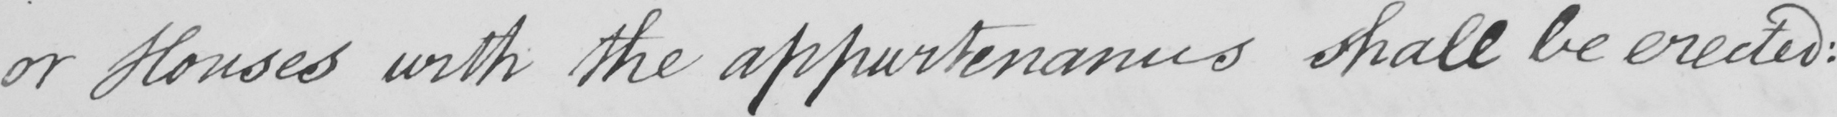What does this handwritten line say? or Houses with the appurtenances shall be erected : 